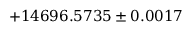<formula> <loc_0><loc_0><loc_500><loc_500>+ 1 4 6 9 6 . 5 7 3 5 \pm 0 . 0 0 1 7</formula> 